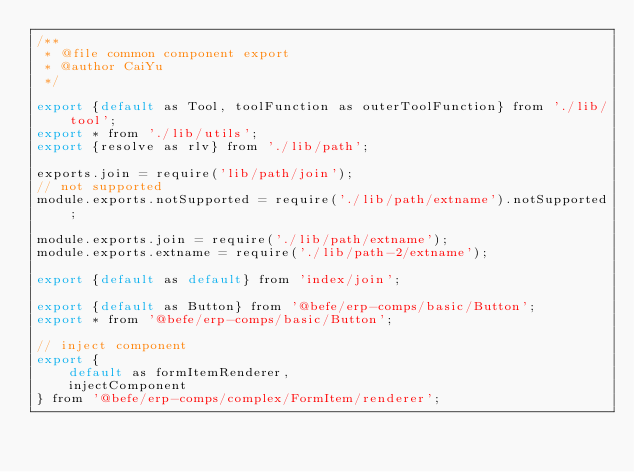Convert code to text. <code><loc_0><loc_0><loc_500><loc_500><_JavaScript_>/**
 * @file common component export
 * @author CaiYu
 */

export {default as Tool, toolFunction as outerToolFunction} from './lib/tool';
export * from './lib/utils';
export {resolve as rlv} from './lib/path';

exports.join = require('lib/path/join');
// not supported
module.exports.notSupported = require('./lib/path/extname').notSupported;

module.exports.join = require('./lib/path/extname');
module.exports.extname = require('./lib/path-2/extname');

export {default as default} from 'index/join';

export {default as Button} from '@befe/erp-comps/basic/Button';
export * from '@befe/erp-comps/basic/Button';

// inject component
export {
    default as formItemRenderer,
    injectComponent
} from '@befe/erp-comps/complex/FormItem/renderer';</code> 